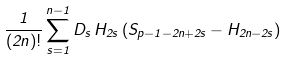<formula> <loc_0><loc_0><loc_500><loc_500>\frac { 1 } { ( 2 n ) ! } \sum _ { s = 1 } ^ { n - 1 } D _ { s } \, H _ { 2 s } \left ( S _ { p - 1 - 2 n + 2 s } - H _ { 2 n - 2 s } \right )</formula> 